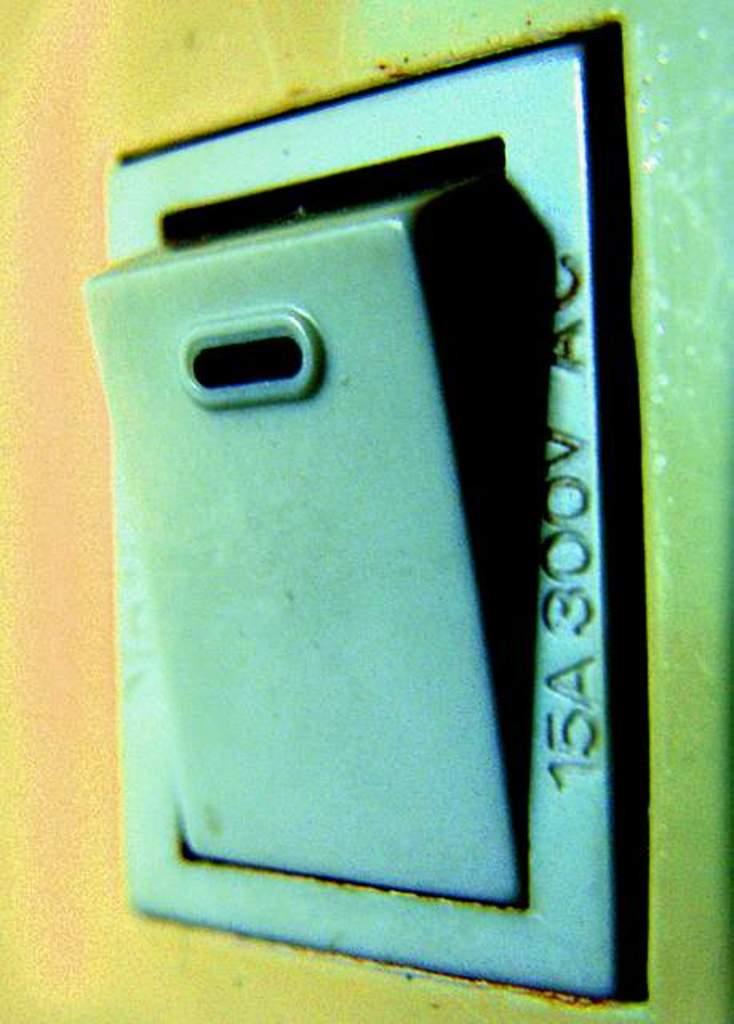What numbers are on the right side?
Give a very brief answer. 15 300. 